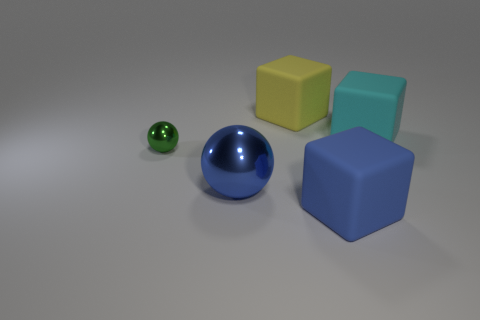Do the colors of these objects follow any specific pattern or theme? The objects do not seem to follow a deliberate color pattern or theme; they exhibit a diverse range of colors. The tiny green ball and the large blue ball share cooler tones, while the yellow and cyan cubes introduce a contrast with a warmer and a cool color respectively. The blue cube repeats the color of the larger ball, suggesting a subtle pairing in the arrangement. 